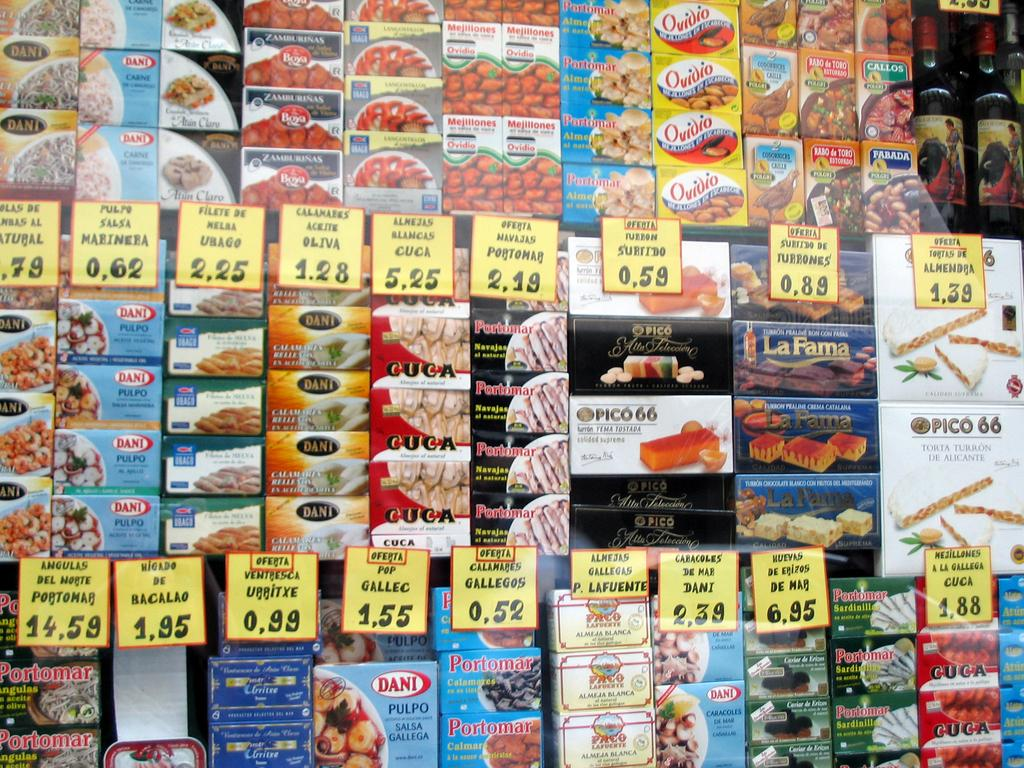<image>
Present a compact description of the photo's key features. A display of foodstuffs, one of which is labelled Dani. 